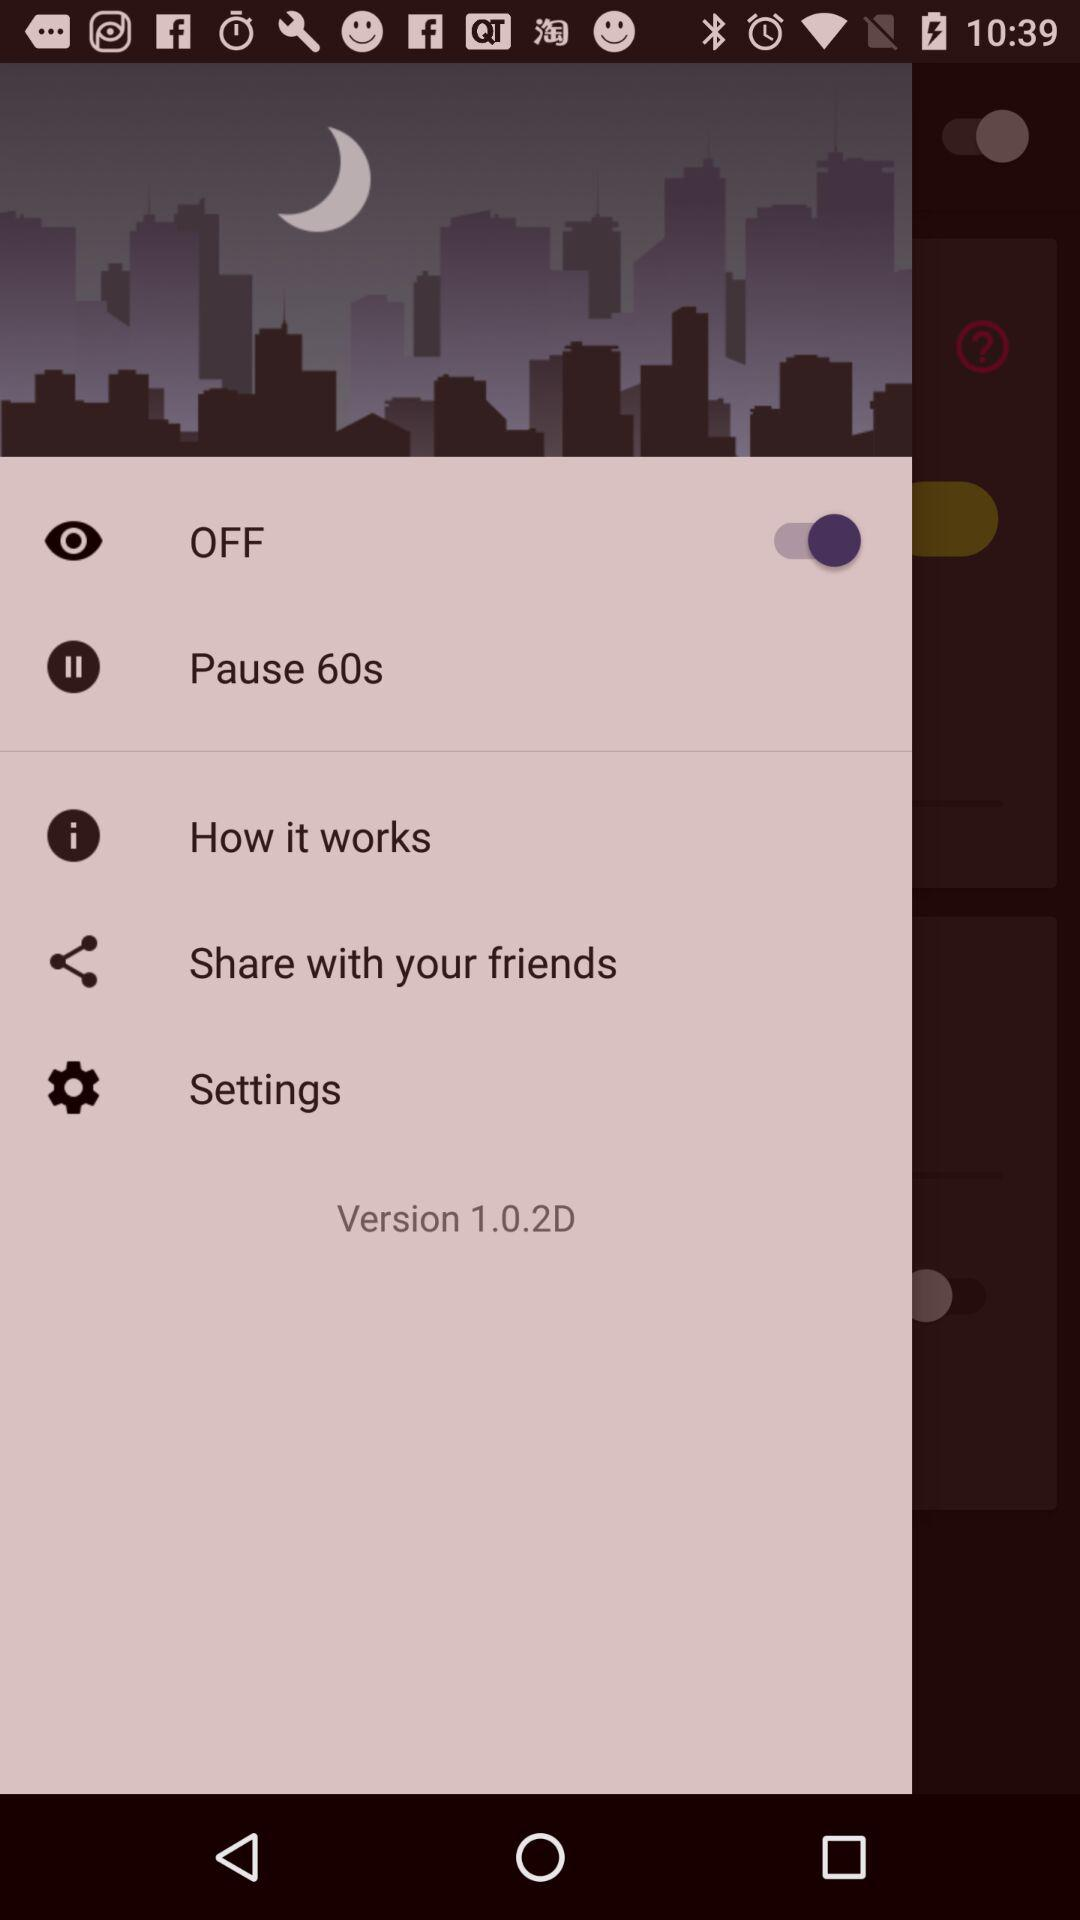What is the given version? The given version is 1.0.2D. 